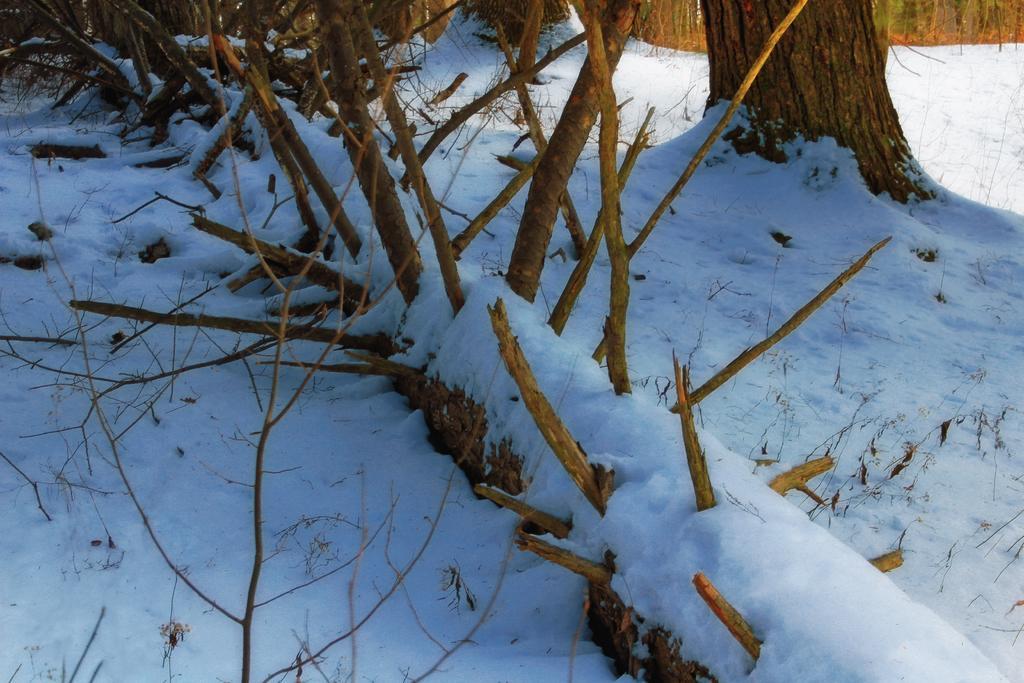How would you summarize this image in a sentence or two? In this image there is a tree on the ground. On the tree there is snow. At the bottom there is snow. In the snow there are some dry sticks. On the right side top there is another tree. 